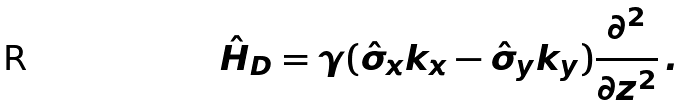<formula> <loc_0><loc_0><loc_500><loc_500>\hat { H } _ { D } = \gamma ( \hat { \sigma } _ { x } k _ { x } - \hat { \sigma } _ { y } k _ { y } ) \frac { \partial ^ { 2 } } { \partial z ^ { 2 } } \, .</formula> 